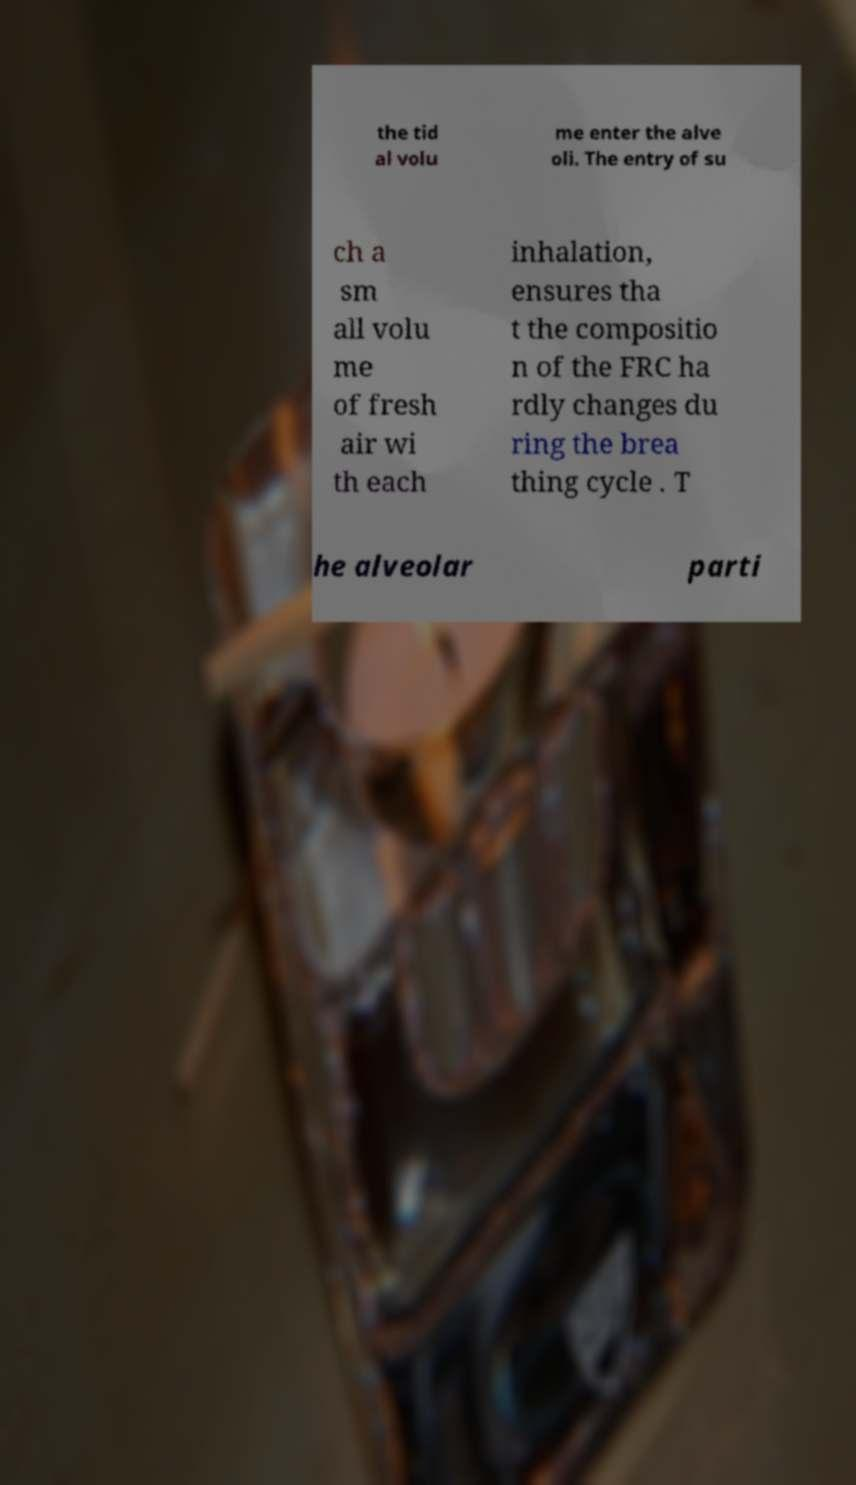There's text embedded in this image that I need extracted. Can you transcribe it verbatim? the tid al volu me enter the alve oli. The entry of su ch a sm all volu me of fresh air wi th each inhalation, ensures tha t the compositio n of the FRC ha rdly changes du ring the brea thing cycle . T he alveolar parti 